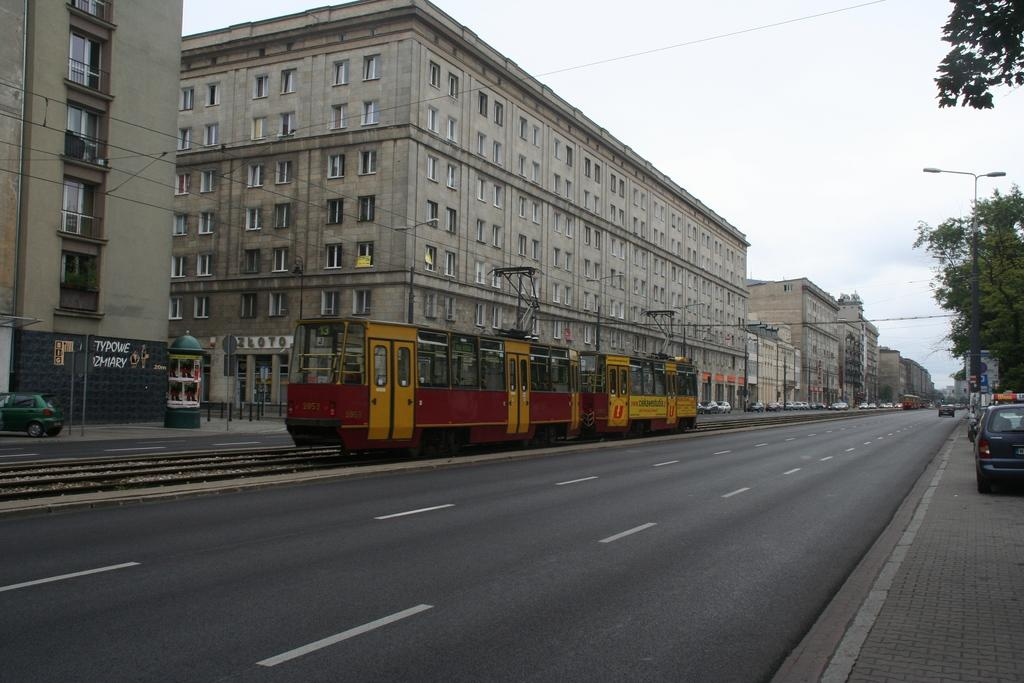What type of structures can be seen in the image? There are buildings in the image. What mode of transportation is present in the image? A train is present in the image. What type of lighting is visible in the image? Street lights are visible in the image. What type of infrastructure is present in the image? Poles and cables are visible in the image. What type of pathway is present in the image? There is a road in the image. What type of natural elements are present in the image? Trees are present in the image. What type of openings are visible in the buildings? Windows are visible in the image. What type of commercial establishments are present in the image? Shops are present in the image. What part of the natural environment is visible in the image? The sky is visible in the image, and clouds are present. What type of yak can be seen grazing on the grass in the image? There is no yak present in the image; the focus is on buildings, vehicles, and other urban elements. How does the image show care for the environment? The image does not specifically show care for the environment, as it is focused on urban infrastructure and does not highlight any environmental initiatives or practices. 